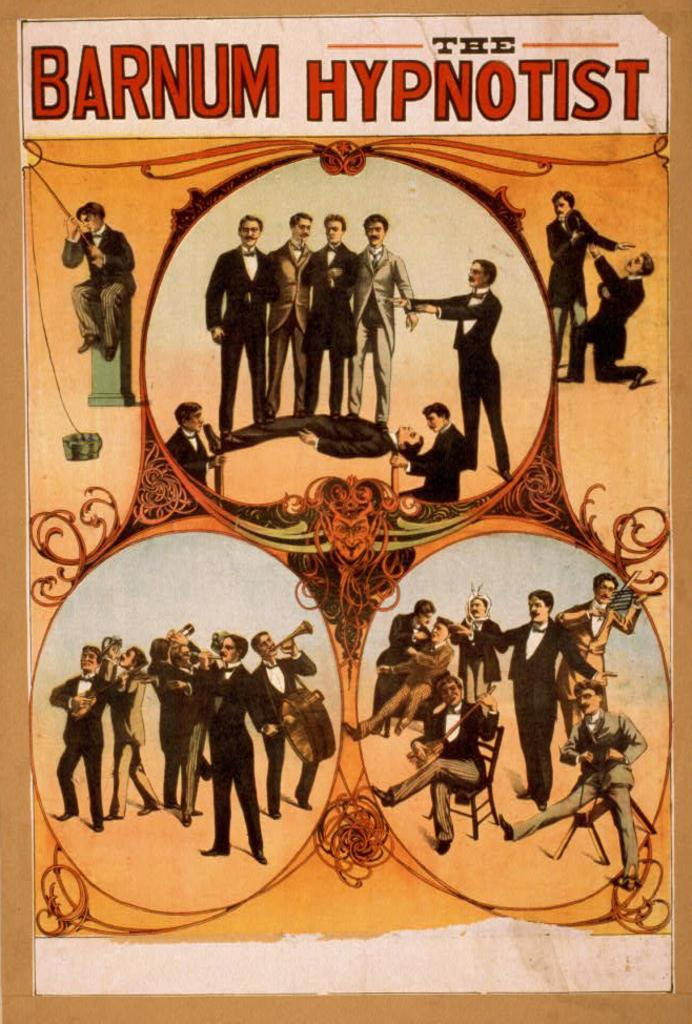<image>
Create a compact narrative representing the image presented. A vintage poster for Barnum's circus The Hypnotist. 